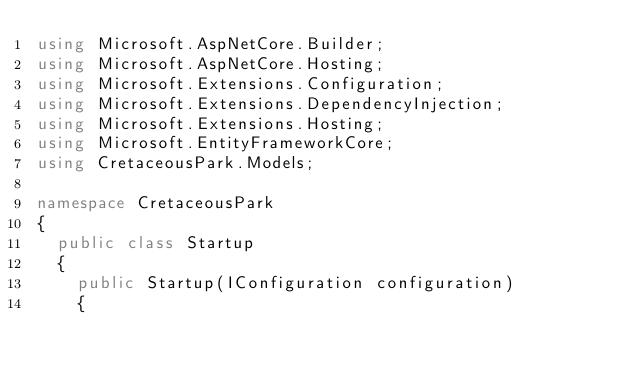<code> <loc_0><loc_0><loc_500><loc_500><_C#_>using Microsoft.AspNetCore.Builder;
using Microsoft.AspNetCore.Hosting;
using Microsoft.Extensions.Configuration;
using Microsoft.Extensions.DependencyInjection;
using Microsoft.Extensions.Hosting;
using Microsoft.EntityFrameworkCore;
using CretaceousPark.Models;

namespace CretaceousPark
{
  public class Startup
  {
    public Startup(IConfiguration configuration)
    {</code> 